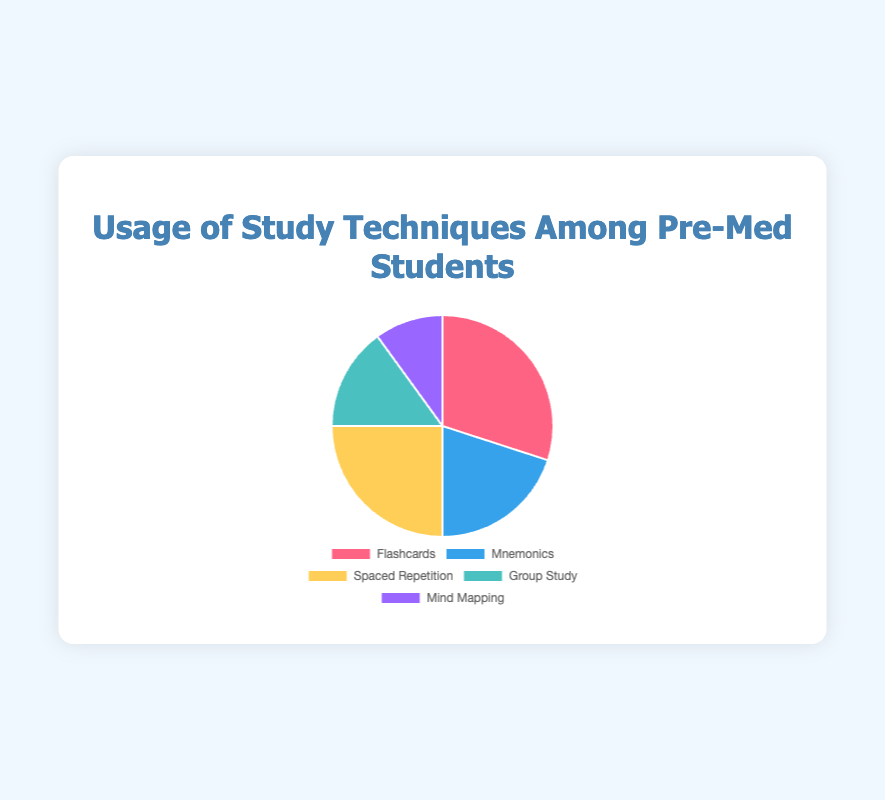What study technique is used by 30% of the students? The pie chart shows that Flashcards is represented by a slice corresponding to 30% of the total usage of study techniques. This is indicated by the section labeled "Flashcards" with a 30% value.
Answer: Flashcards Which study technique has the lowest usage percentage among pre-med students? The pie chart shows that Mind Mapping occupies the smallest segment with a 10% usage, indicating it is the least used study technique among pre-med students.
Answer: Mind Mapping Which two study techniques combined account for half of the usage among pre-med students? By adding the percentage values for Flashcards and Spaced Repetition, we get 30% + 25% = 55%, which is more than 50%. To account for exactly half, we combine Mnemonics (20%) and Spaced Repetition (25%): 20% + 25% = 45%. Thus, Flashcards and Spaced Repetition continue to be a viable combination.
Answer: Flashcards and Spaced Repetition What is the difference in usage percentage between Group Study and Mnemonics? From the pie chart: Mnemonics has a usage of 20%, and Group Study has 15%. Subtracting these values gives 20% - 15% = 5%.
Answer: 5% How much more popular is the most used study technique compared to the least used one? The most used technique is Flashcards at 30%, and the least used technique is Mind Mapping at 10%. The difference between these values is 30% - 10% = 20%.
Answer: 20% Which study technique usage percentage is represented by a yellow segment? The pie chart's legend indicates the yellow segment is for Spaced Repetition, which has a 25% usage.
Answer: Spaced Repetition What is the average percentage usage of all study techniques? To find the average, sum all the percentages: 30 (Flashcards) + 20 (Mnemonics) + 25 (Spaced Repetition) + 15 (Group Study) + 10 (Mind Mapping) = 100%. Dividing this by the number of techniques (5) gives an average of 100% / 5 = 20%.
Answer: 20% If the usage of Mind Mapping doubles, what would be its new percentage and how would it compare to the usage of Mnemonics? If Mind Mapping's usage doubles, its percentage will be 10% * 2 = 20%. This will make the usage of Mind Mapping equal to Mnemonics, both having 20%.
Answer: 20%, equal to Mnemonics Which three study techniques together constitute 75% of the total usage? Adding the percentages of Flashcards (30%), Spaced Repetition (25%), and Mnemonics (20%) gives 30% + 25% + 20% = 75%.
Answer: Flashcards, Spaced Repetition, and Mnemonics 